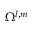<formula> <loc_0><loc_0><loc_500><loc_500>\Omega ^ { l , m }</formula> 